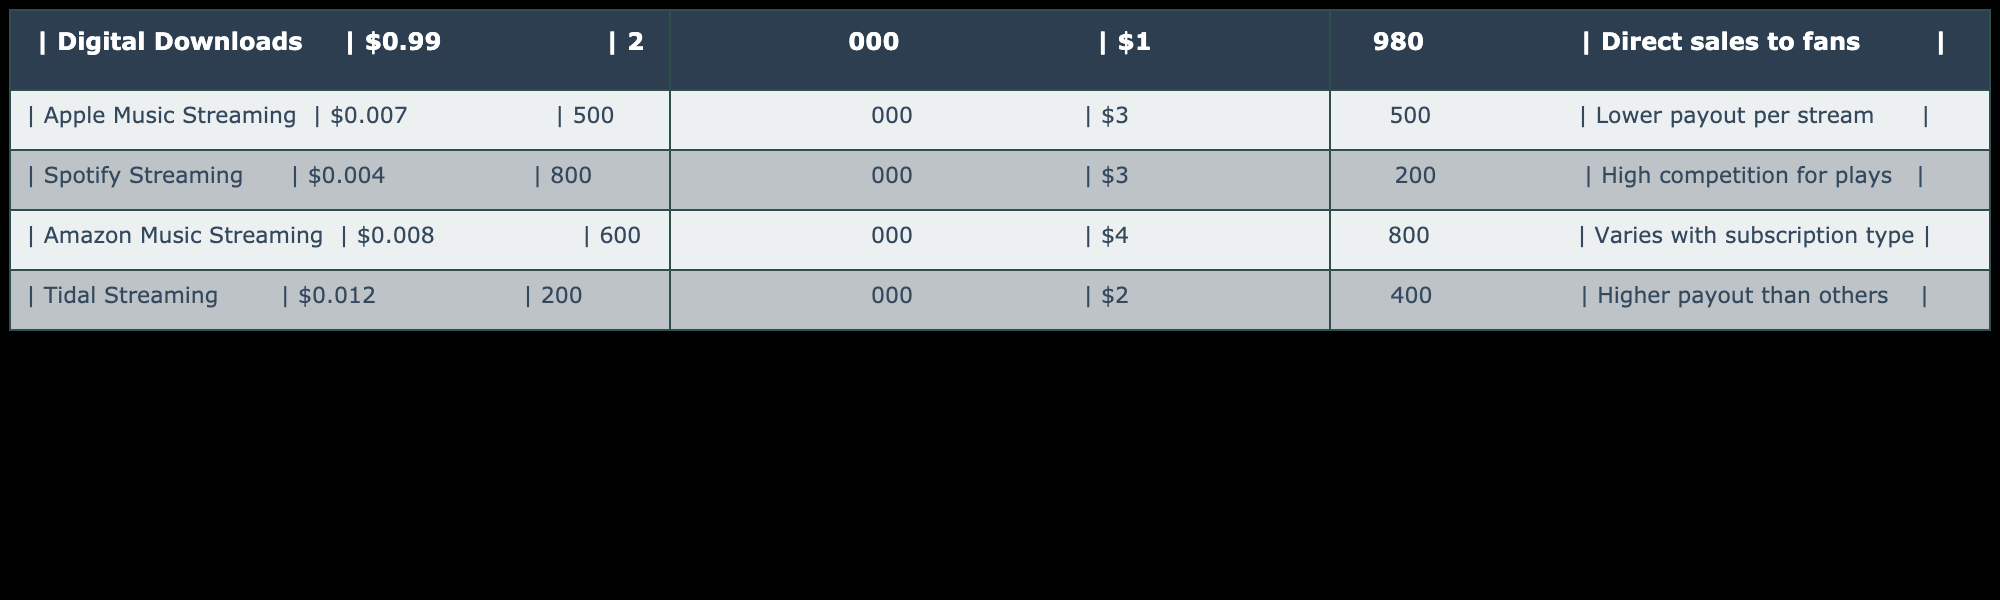What is the revenue from digital downloads? The table shows the revenue from digital downloads listed as $1,980. Therefore, this is the value directly stated in the 'Revenue' column for digital downloads.
Answer: $1,980 What is the payout per stream for Apple Music? The payout per stream for Apple Music is given as $0.007 in the 'Per Unit Revenue' column for Apple Music Streaming.
Answer: $0.007 Which streaming service provides the highest revenue? Looking at the 'Revenue' column, Amazon Music Streaming has the highest revenue at $4,800, compared to others such as Apple Music at $3,500 and Spotify at $3,200.
Answer: Amazon Music Streaming What is the total revenue generated from streaming platforms? To find the total revenue, we sum the revenue from all streaming services: $3,500 (Apple Music) + $3,200 (Spotify) + $4,800 (Amazon Music) + $2,400 (Tidal) = $13,900.
Answer: $13,900 Is it true that Tidal has a higher payout per stream than Amazon Music? Tidal has a payout of $0.012 per stream, while Amazon Music has $0.008. Since $0.012 is greater than $0.008, this statement is true.
Answer: Yes Which streaming service has the lowest payout per stream? The table shows that Spotify has the lowest payout per stream at $0.004. This is compared to the other streaming services listed.
Answer: Spotify What is the average payout per stream across all streaming platforms? To find the average, we add the payouts: $0.007 (Apple Music) + $0.004 (Spotify) + $0.008 (Amazon) + $0.012 (Tidal) = $0.031. Dividing by the number of platforms (4) gives us $0.031 / 4 = $0.00775.
Answer: $0.00775 What is the revenue difference between digital downloads and Spotify streaming? The difference is calculated by subtracting Spotify streaming revenue ($3,200) from digital downloads revenue ($1,980): $1,980 - $3,200 = -$1,220. Hence, the revenue from digital downloads is lower.
Answer: -$1,220 Does direct sales to fans provide a higher revenue compared to any streaming service? Digital downloads revenue is $1,980, which is higher than Apple Music ($3,500), Spotify ($3,200), and Tidal ($2,400), but lower than Amazon Music ($4,800). Therefore, it provides a higher revenue compared to most streaming services except Amazon Music.
Answer: No 